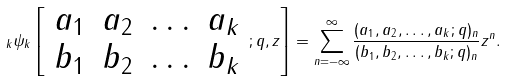<formula> <loc_0><loc_0><loc_500><loc_500>\, _ { k } \psi _ { k } \left [ { \begin{array} { l l l l } { a _ { 1 } } & { a _ { 2 } } & { \dots } & { a _ { k } } \\ { b _ { 1 } } & { b _ { 2 } } & { \dots } & { b _ { k } } \end{array} } ; q , z \right ] = \sum _ { n = - \infty } ^ { \infty } { \frac { ( a _ { 1 } , a _ { 2 } , \dots , a _ { k } ; q ) _ { n } } { ( b _ { 1 } , b _ { 2 } , \dots , b _ { k } ; q ) _ { n } } } z ^ { n } .</formula> 